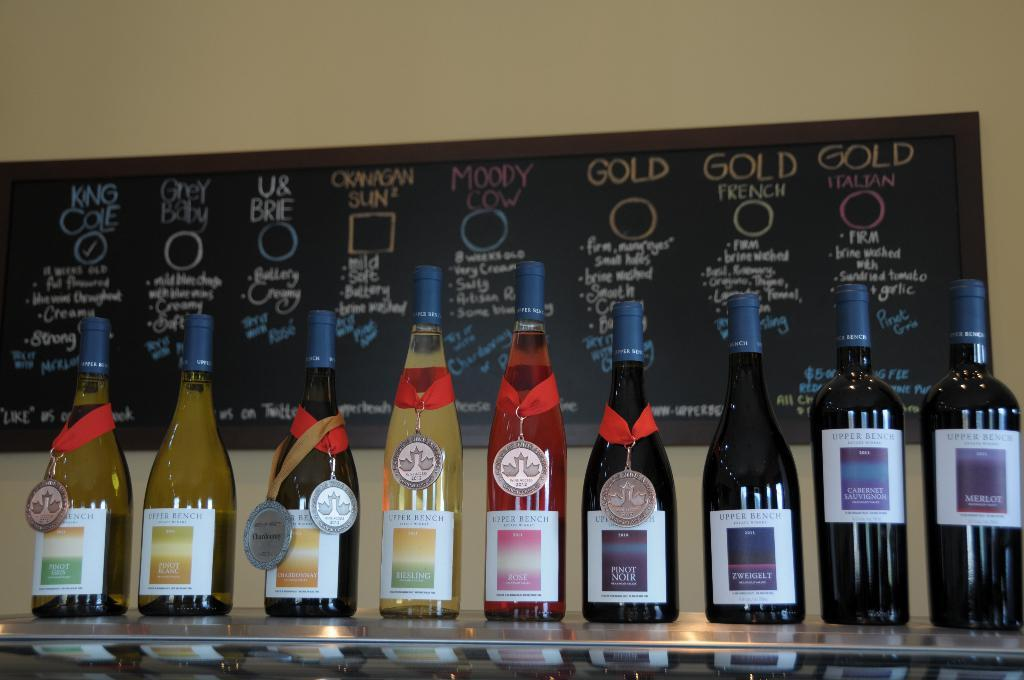<image>
Share a concise interpretation of the image provided. the word pinot noir that is on the glass 